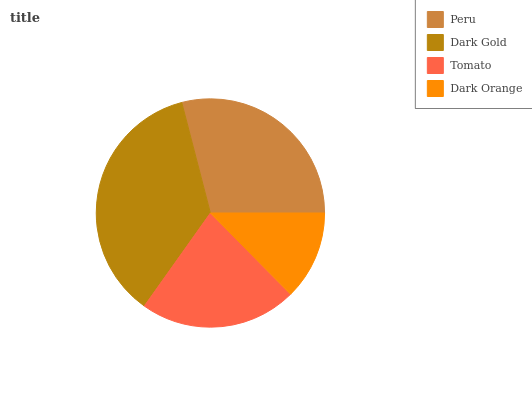Is Dark Orange the minimum?
Answer yes or no. Yes. Is Dark Gold the maximum?
Answer yes or no. Yes. Is Tomato the minimum?
Answer yes or no. No. Is Tomato the maximum?
Answer yes or no. No. Is Dark Gold greater than Tomato?
Answer yes or no. Yes. Is Tomato less than Dark Gold?
Answer yes or no. Yes. Is Tomato greater than Dark Gold?
Answer yes or no. No. Is Dark Gold less than Tomato?
Answer yes or no. No. Is Peru the high median?
Answer yes or no. Yes. Is Tomato the low median?
Answer yes or no. Yes. Is Dark Orange the high median?
Answer yes or no. No. Is Dark Orange the low median?
Answer yes or no. No. 